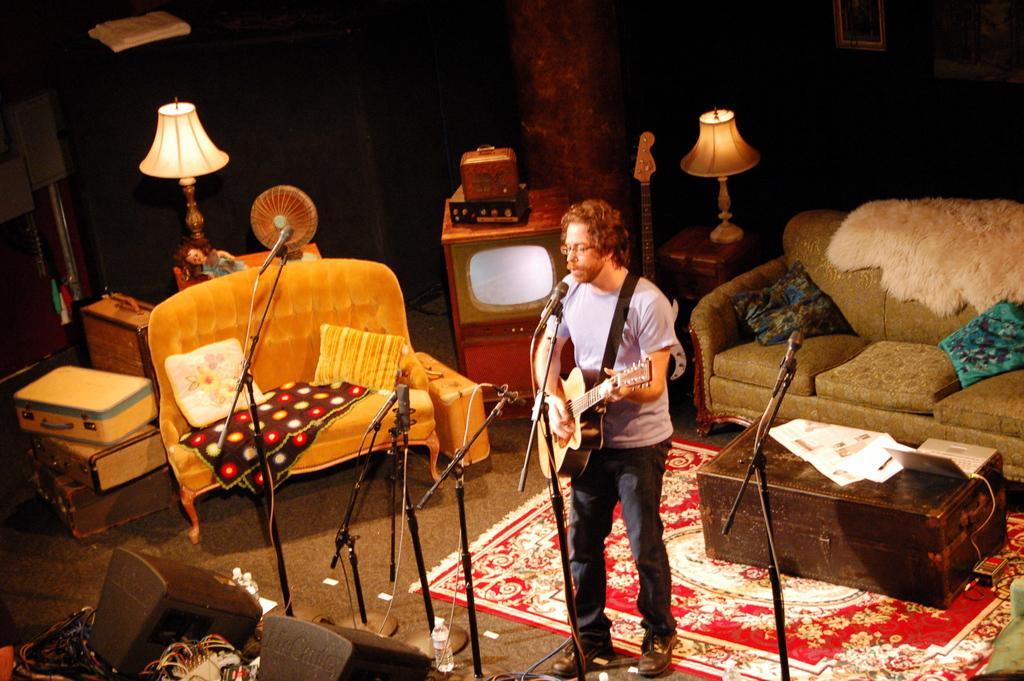Please provide a concise description of this image. In this room there is sofa on the right side and a table in front of it and a carpet on the floor. The man singing on a mic holding guitar in his hand. There are mic and mic stand on the floor. Lamp is placed on the table in front of small sofa with cushion and cloth on it and beside there is a suitcase and there is tv beside the suitcase. 